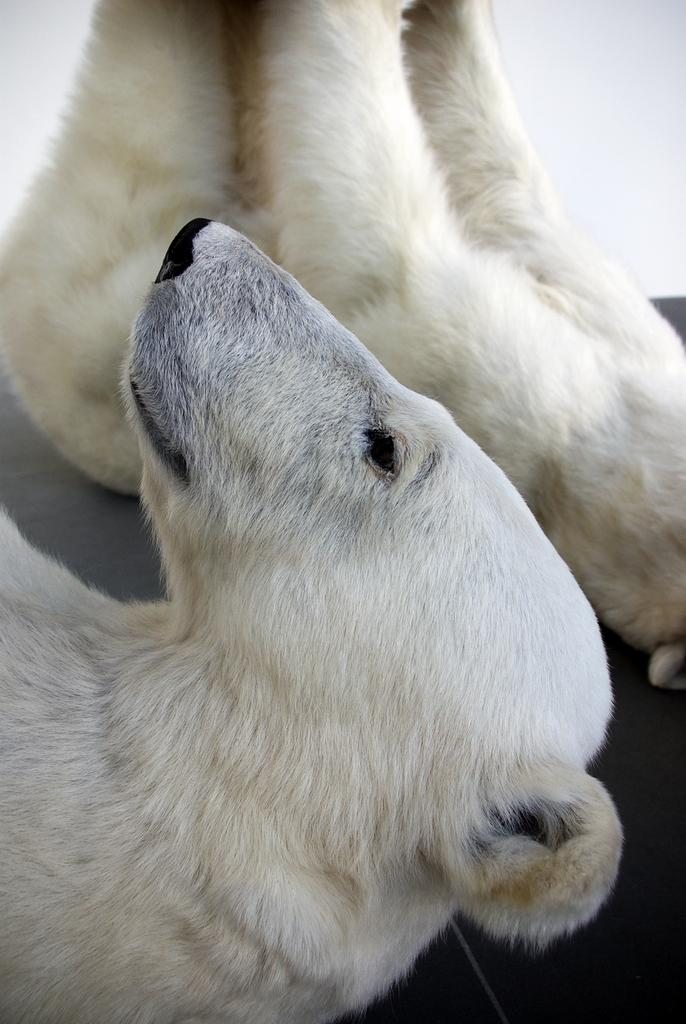How many polar bears are in the image? There are two polar bears in the image. What is the appearance of the polar bears in the image? The polar bears appear to be truncated or partially visible. What surface are the polar bears on in the image? The polar bears are on a surface in the image. What is the color of the background in the image? The background of the image is white in color. What type of underwear is the polar bear wearing in the image? Polar bears do not wear underwear, and there is no underwear visible in the image. Was the inclusion of the polar bears an afterthought in the creation of the image? There is no information provided about the creation process of the image, so it cannot be determined if the polar bears were an afterthought. 